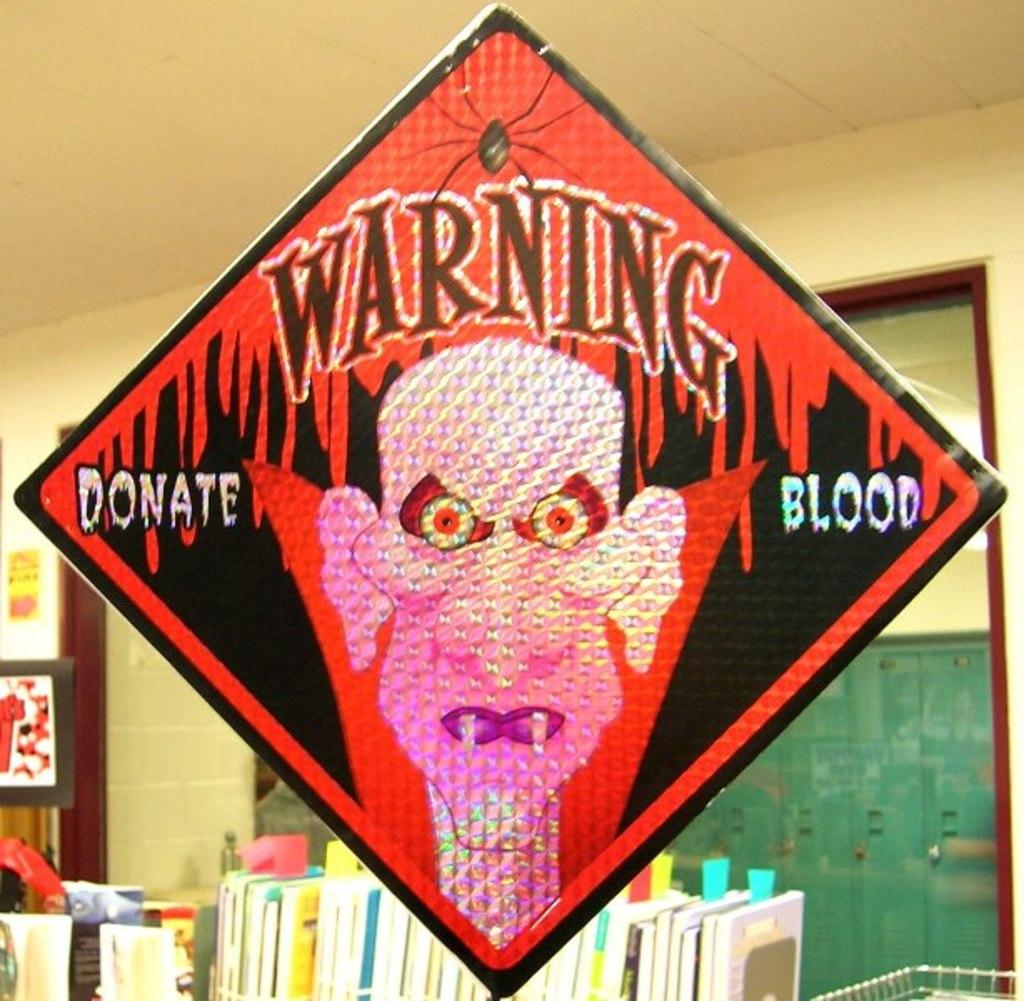Provide a one-sentence caption for the provided image. A sign with a vampire that says Warning Donate Blood. 